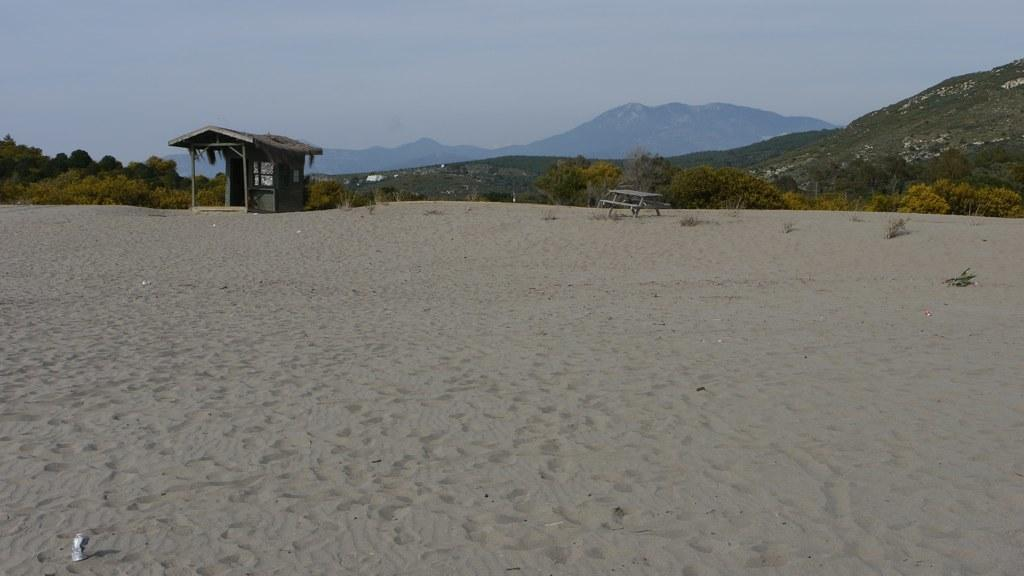What type of terrain is visible in the image? There is sand in the image. What type of structure can be seen in the image? There is a house in the image. What type of seating is present in the image? There is a bench in the image. What can be seen in the background of the image? There are trees, mountains, and the sky visible in the background of the image. What type of wood is used to make the scissors in the image? There are no scissors present in the image. What time of day is it in the image, considering the afternoon? The time of day cannot be determined from the image, as there is no indication of the time. 